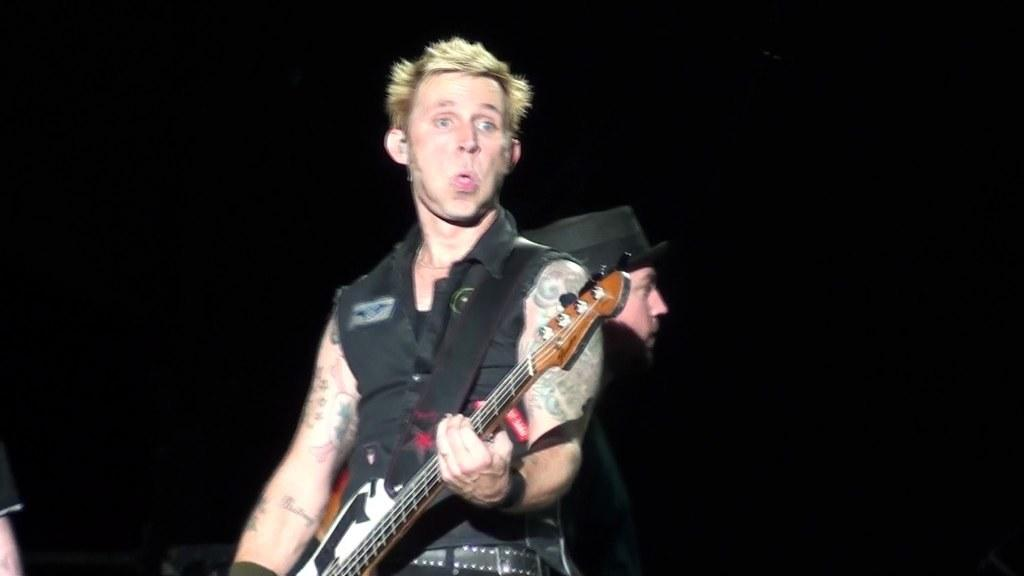What is the person in the image wearing? The person is wearing a black dress. What is the person holding in the image? The person is holding a guitar. Can you describe the second person in the image? The second person is wearing a hat. What is the color of the background in the image? The background of the image is black. What type of rock is the person offering to the second person in the image? There is no rock present in the image, and no offer is being made between the two people. 